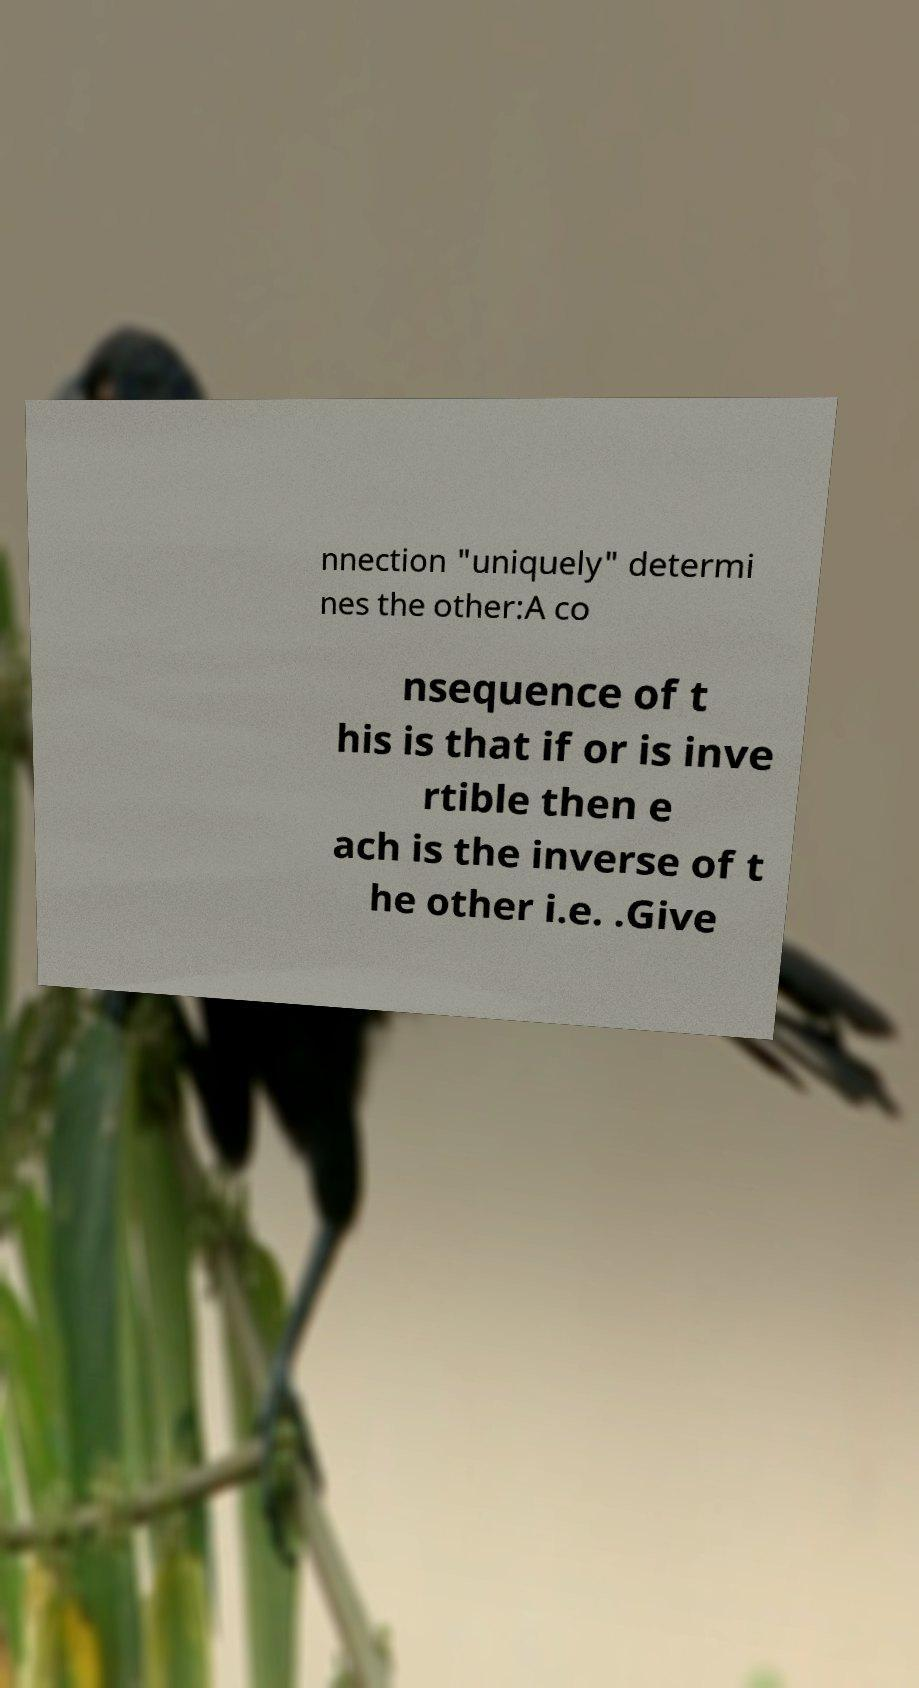Please read and relay the text visible in this image. What does it say? nnection "uniquely" determi nes the other:A co nsequence of t his is that if or is inve rtible then e ach is the inverse of t he other i.e. .Give 